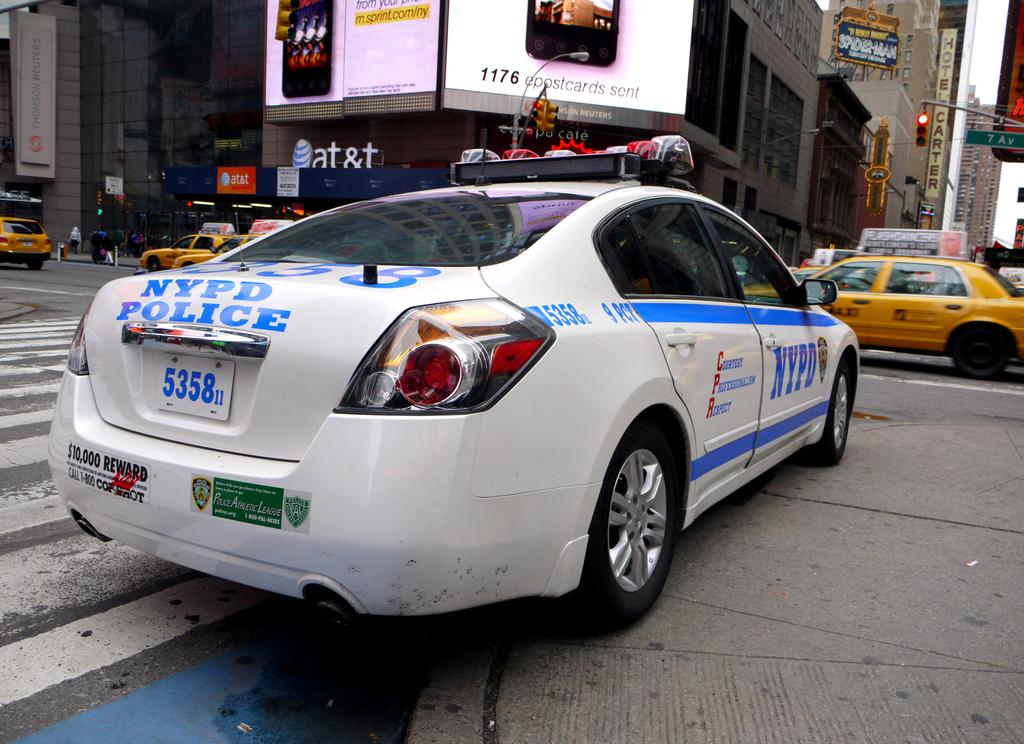<image>
Present a compact description of the photo's key features. A white NYPD Police car sitting at a red stoplight. 